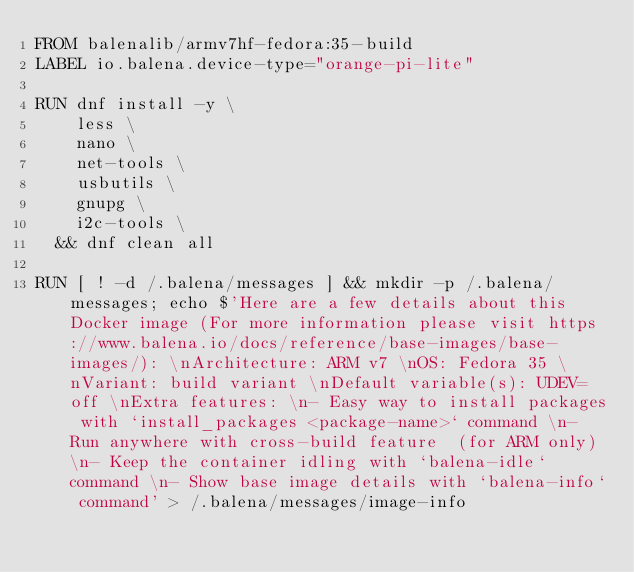Convert code to text. <code><loc_0><loc_0><loc_500><loc_500><_Dockerfile_>FROM balenalib/armv7hf-fedora:35-build
LABEL io.balena.device-type="orange-pi-lite"

RUN dnf install -y \
		less \
		nano \
		net-tools \
		usbutils \
		gnupg \
		i2c-tools \
	&& dnf clean all

RUN [ ! -d /.balena/messages ] && mkdir -p /.balena/messages; echo $'Here are a few details about this Docker image (For more information please visit https://www.balena.io/docs/reference/base-images/base-images/): \nArchitecture: ARM v7 \nOS: Fedora 35 \nVariant: build variant \nDefault variable(s): UDEV=off \nExtra features: \n- Easy way to install packages with `install_packages <package-name>` command \n- Run anywhere with cross-build feature  (for ARM only) \n- Keep the container idling with `balena-idle` command \n- Show base image details with `balena-info` command' > /.balena/messages/image-info</code> 